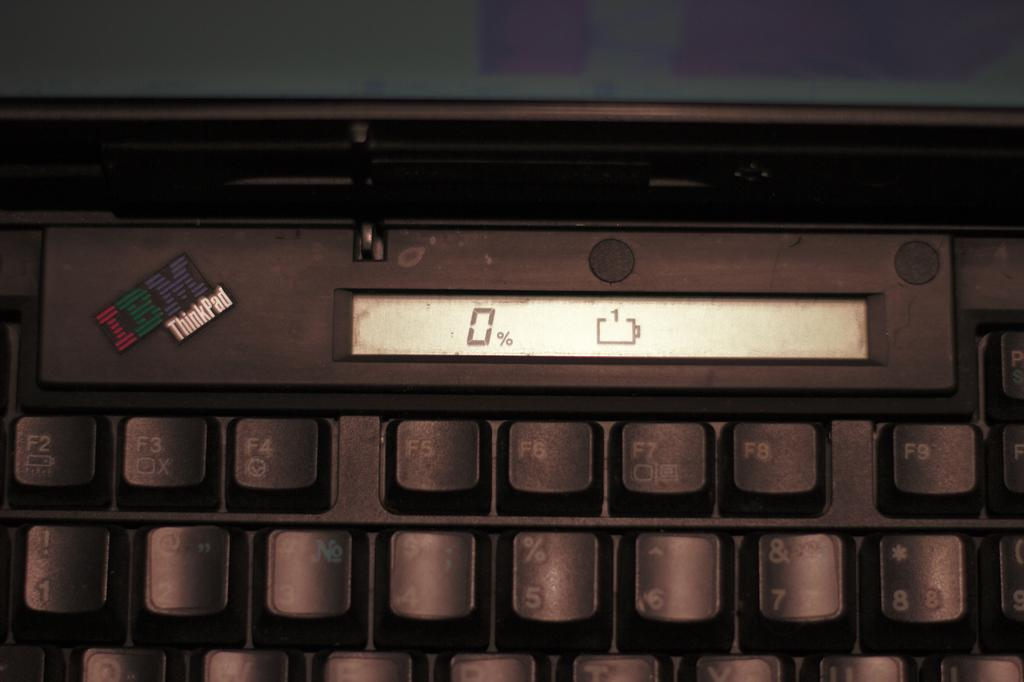<image>
Offer a succinct explanation of the picture presented. An IBM ThinkPad displays 0% on its screen. 